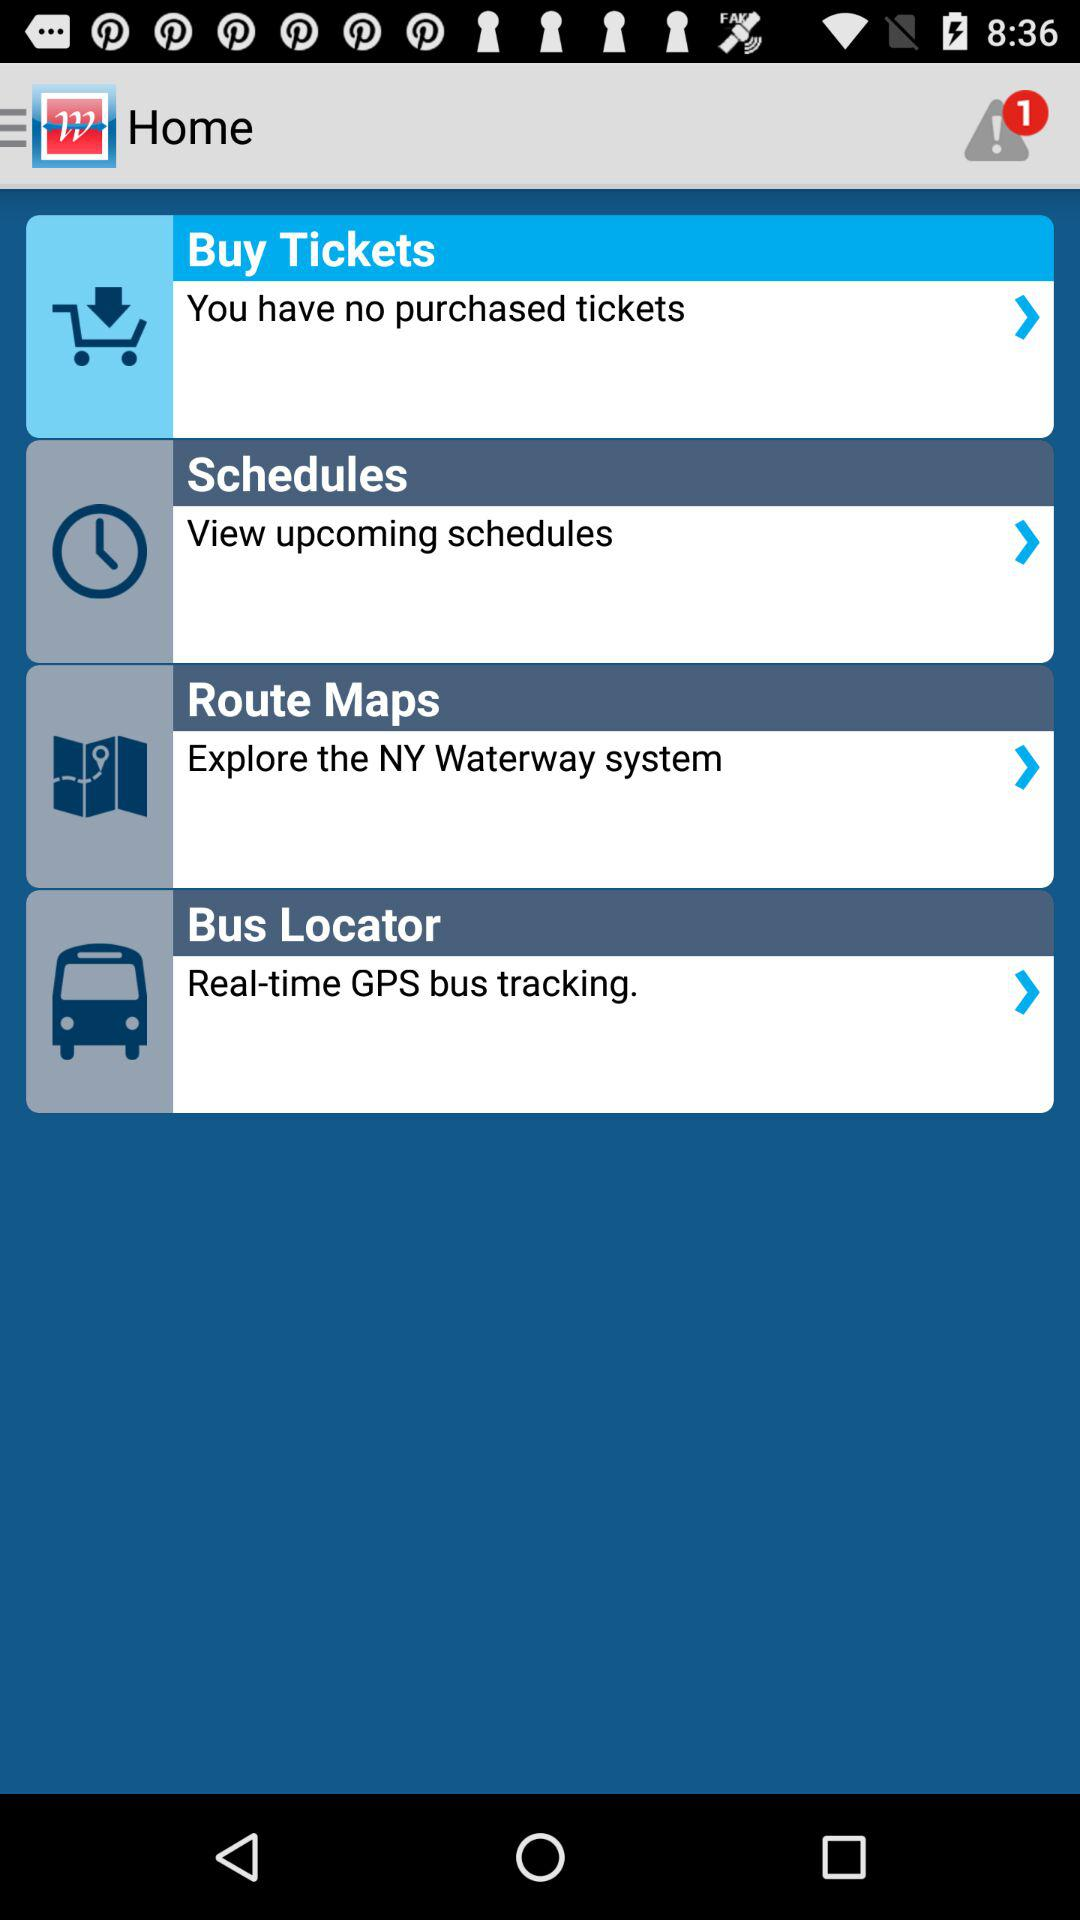How many unread notifications are shown? The shown number of unread notifications is 1. 